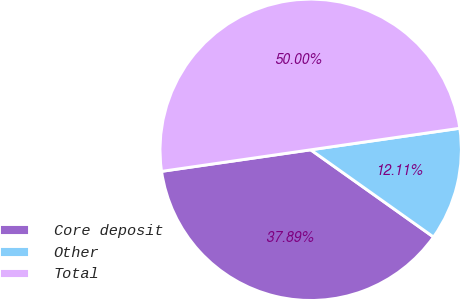<chart> <loc_0><loc_0><loc_500><loc_500><pie_chart><fcel>Core deposit<fcel>Other<fcel>Total<nl><fcel>37.89%<fcel>12.11%<fcel>50.0%<nl></chart> 